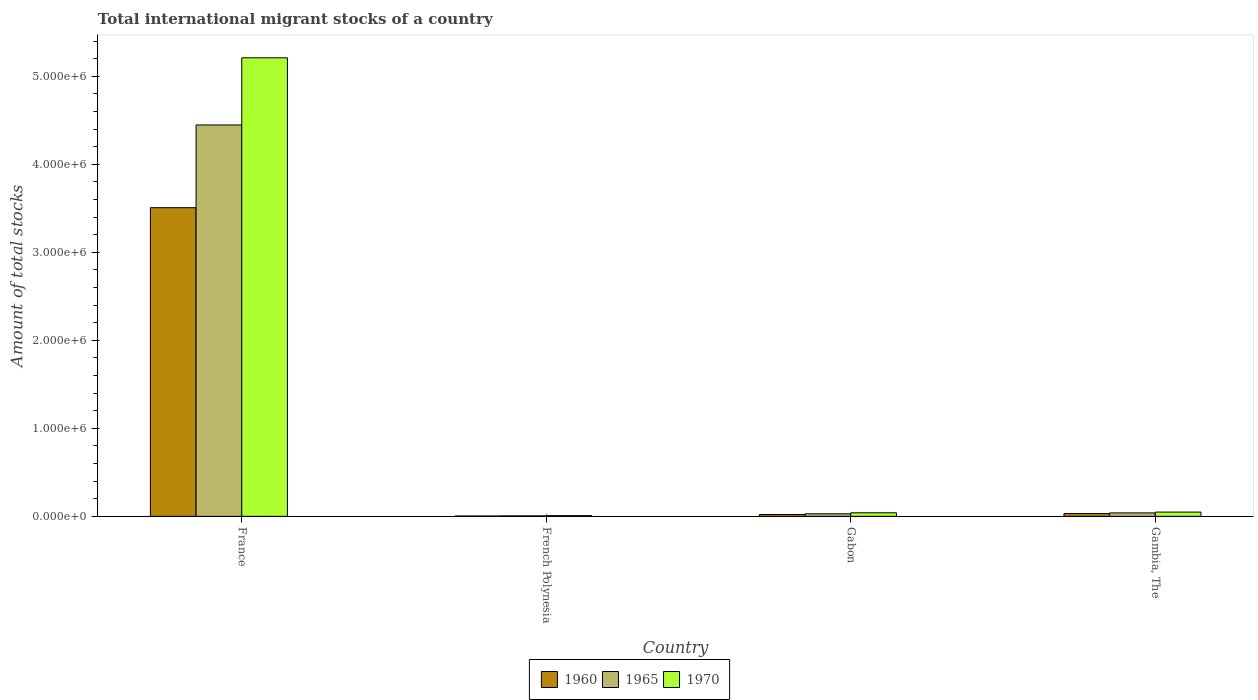How many groups of bars are there?
Make the answer very short. 4. Are the number of bars per tick equal to the number of legend labels?
Provide a short and direct response. Yes. How many bars are there on the 3rd tick from the left?
Ensure brevity in your answer.  3. What is the label of the 4th group of bars from the left?
Offer a terse response. Gambia, The. In how many cases, is the number of bars for a given country not equal to the number of legend labels?
Keep it short and to the point. 0. What is the amount of total stocks in in 1970 in French Polynesia?
Your answer should be very brief. 8194. Across all countries, what is the maximum amount of total stocks in in 1960?
Your response must be concise. 3.51e+06. Across all countries, what is the minimum amount of total stocks in in 1965?
Give a very brief answer. 5480. In which country was the amount of total stocks in in 1970 maximum?
Provide a short and direct response. France. In which country was the amount of total stocks in in 1960 minimum?
Offer a terse response. French Polynesia. What is the total amount of total stocks in in 1960 in the graph?
Your answer should be very brief. 3.56e+06. What is the difference between the amount of total stocks in in 1965 in France and that in Gabon?
Give a very brief answer. 4.42e+06. What is the difference between the amount of total stocks in in 1970 in Gambia, The and the amount of total stocks in in 1965 in French Polynesia?
Make the answer very short. 4.29e+04. What is the average amount of total stocks in in 1960 per country?
Offer a terse response. 8.91e+05. What is the difference between the amount of total stocks in of/in 1965 and amount of total stocks in of/in 1970 in France?
Make the answer very short. -7.63e+05. In how many countries, is the amount of total stocks in in 1960 greater than 4200000?
Provide a succinct answer. 0. What is the ratio of the amount of total stocks in in 1970 in France to that in Gambia, The?
Offer a very short reply. 107.68. Is the amount of total stocks in in 1960 in Gabon less than that in Gambia, The?
Provide a short and direct response. Yes. Is the difference between the amount of total stocks in in 1965 in France and Gabon greater than the difference between the amount of total stocks in in 1970 in France and Gabon?
Provide a short and direct response. No. What is the difference between the highest and the second highest amount of total stocks in in 1965?
Provide a succinct answer. 1.00e+04. What is the difference between the highest and the lowest amount of total stocks in in 1960?
Keep it short and to the point. 3.50e+06. In how many countries, is the amount of total stocks in in 1960 greater than the average amount of total stocks in in 1960 taken over all countries?
Offer a very short reply. 1. What does the 1st bar from the left in Gabon represents?
Offer a very short reply. 1960. Is it the case that in every country, the sum of the amount of total stocks in in 1970 and amount of total stocks in in 1960 is greater than the amount of total stocks in in 1965?
Offer a very short reply. Yes. Are all the bars in the graph horizontal?
Make the answer very short. No. How many countries are there in the graph?
Your answer should be compact. 4. What is the difference between two consecutive major ticks on the Y-axis?
Give a very brief answer. 1.00e+06. Does the graph contain any zero values?
Ensure brevity in your answer.  No. Does the graph contain grids?
Make the answer very short. No. How many legend labels are there?
Your answer should be very brief. 3. How are the legend labels stacked?
Make the answer very short. Horizontal. What is the title of the graph?
Your answer should be very brief. Total international migrant stocks of a country. What is the label or title of the X-axis?
Your response must be concise. Country. What is the label or title of the Y-axis?
Your answer should be compact. Amount of total stocks. What is the Amount of total stocks in 1960 in France?
Offer a terse response. 3.51e+06. What is the Amount of total stocks of 1965 in France?
Offer a very short reply. 4.45e+06. What is the Amount of total stocks of 1970 in France?
Offer a very short reply. 5.21e+06. What is the Amount of total stocks of 1960 in French Polynesia?
Offer a very short reply. 3665. What is the Amount of total stocks in 1965 in French Polynesia?
Offer a very short reply. 5480. What is the Amount of total stocks in 1970 in French Polynesia?
Your answer should be compact. 8194. What is the Amount of total stocks of 1960 in Gabon?
Offer a terse response. 2.09e+04. What is the Amount of total stocks of 1965 in Gabon?
Keep it short and to the point. 2.90e+04. What is the Amount of total stocks in 1970 in Gabon?
Provide a short and direct response. 4.04e+04. What is the Amount of total stocks of 1960 in Gambia, The?
Provide a short and direct response. 3.16e+04. What is the Amount of total stocks of 1965 in Gambia, The?
Your answer should be very brief. 3.91e+04. What is the Amount of total stocks in 1970 in Gambia, The?
Make the answer very short. 4.84e+04. Across all countries, what is the maximum Amount of total stocks of 1960?
Provide a succinct answer. 3.51e+06. Across all countries, what is the maximum Amount of total stocks in 1965?
Your answer should be compact. 4.45e+06. Across all countries, what is the maximum Amount of total stocks in 1970?
Offer a terse response. 5.21e+06. Across all countries, what is the minimum Amount of total stocks in 1960?
Your answer should be very brief. 3665. Across all countries, what is the minimum Amount of total stocks in 1965?
Your answer should be very brief. 5480. Across all countries, what is the minimum Amount of total stocks of 1970?
Your answer should be very brief. 8194. What is the total Amount of total stocks of 1960 in the graph?
Your answer should be very brief. 3.56e+06. What is the total Amount of total stocks in 1965 in the graph?
Your response must be concise. 4.52e+06. What is the total Amount of total stocks in 1970 in the graph?
Ensure brevity in your answer.  5.31e+06. What is the difference between the Amount of total stocks in 1960 in France and that in French Polynesia?
Your answer should be compact. 3.50e+06. What is the difference between the Amount of total stocks of 1965 in France and that in French Polynesia?
Offer a very short reply. 4.44e+06. What is the difference between the Amount of total stocks in 1970 in France and that in French Polynesia?
Keep it short and to the point. 5.20e+06. What is the difference between the Amount of total stocks of 1960 in France and that in Gabon?
Your response must be concise. 3.49e+06. What is the difference between the Amount of total stocks in 1965 in France and that in Gabon?
Your answer should be very brief. 4.42e+06. What is the difference between the Amount of total stocks in 1970 in France and that in Gabon?
Your answer should be very brief. 5.17e+06. What is the difference between the Amount of total stocks of 1960 in France and that in Gambia, The?
Provide a succinct answer. 3.48e+06. What is the difference between the Amount of total stocks of 1965 in France and that in Gambia, The?
Give a very brief answer. 4.41e+06. What is the difference between the Amount of total stocks of 1970 in France and that in Gambia, The?
Provide a short and direct response. 5.16e+06. What is the difference between the Amount of total stocks in 1960 in French Polynesia and that in Gabon?
Your answer should be very brief. -1.72e+04. What is the difference between the Amount of total stocks in 1965 in French Polynesia and that in Gabon?
Keep it short and to the point. -2.36e+04. What is the difference between the Amount of total stocks of 1970 in French Polynesia and that in Gabon?
Offer a terse response. -3.22e+04. What is the difference between the Amount of total stocks in 1960 in French Polynesia and that in Gambia, The?
Give a very brief answer. -2.79e+04. What is the difference between the Amount of total stocks of 1965 in French Polynesia and that in Gambia, The?
Ensure brevity in your answer.  -3.36e+04. What is the difference between the Amount of total stocks of 1970 in French Polynesia and that in Gambia, The?
Offer a terse response. -4.02e+04. What is the difference between the Amount of total stocks in 1960 in Gabon and that in Gambia, The?
Make the answer very short. -1.07e+04. What is the difference between the Amount of total stocks in 1965 in Gabon and that in Gambia, The?
Your answer should be compact. -1.00e+04. What is the difference between the Amount of total stocks of 1970 in Gabon and that in Gambia, The?
Your answer should be very brief. -7998. What is the difference between the Amount of total stocks of 1960 in France and the Amount of total stocks of 1965 in French Polynesia?
Provide a succinct answer. 3.50e+06. What is the difference between the Amount of total stocks of 1960 in France and the Amount of total stocks of 1970 in French Polynesia?
Ensure brevity in your answer.  3.50e+06. What is the difference between the Amount of total stocks in 1965 in France and the Amount of total stocks in 1970 in French Polynesia?
Make the answer very short. 4.44e+06. What is the difference between the Amount of total stocks in 1960 in France and the Amount of total stocks in 1965 in Gabon?
Provide a succinct answer. 3.48e+06. What is the difference between the Amount of total stocks in 1960 in France and the Amount of total stocks in 1970 in Gabon?
Your answer should be compact. 3.47e+06. What is the difference between the Amount of total stocks in 1965 in France and the Amount of total stocks in 1970 in Gabon?
Make the answer very short. 4.41e+06. What is the difference between the Amount of total stocks in 1960 in France and the Amount of total stocks in 1965 in Gambia, The?
Keep it short and to the point. 3.47e+06. What is the difference between the Amount of total stocks in 1960 in France and the Amount of total stocks in 1970 in Gambia, The?
Keep it short and to the point. 3.46e+06. What is the difference between the Amount of total stocks in 1965 in France and the Amount of total stocks in 1970 in Gambia, The?
Offer a terse response. 4.40e+06. What is the difference between the Amount of total stocks in 1960 in French Polynesia and the Amount of total stocks in 1965 in Gabon?
Provide a short and direct response. -2.54e+04. What is the difference between the Amount of total stocks of 1960 in French Polynesia and the Amount of total stocks of 1970 in Gabon?
Your response must be concise. -3.67e+04. What is the difference between the Amount of total stocks of 1965 in French Polynesia and the Amount of total stocks of 1970 in Gabon?
Ensure brevity in your answer.  -3.49e+04. What is the difference between the Amount of total stocks in 1960 in French Polynesia and the Amount of total stocks in 1965 in Gambia, The?
Keep it short and to the point. -3.54e+04. What is the difference between the Amount of total stocks of 1960 in French Polynesia and the Amount of total stocks of 1970 in Gambia, The?
Your answer should be compact. -4.47e+04. What is the difference between the Amount of total stocks in 1965 in French Polynesia and the Amount of total stocks in 1970 in Gambia, The?
Keep it short and to the point. -4.29e+04. What is the difference between the Amount of total stocks in 1960 in Gabon and the Amount of total stocks in 1965 in Gambia, The?
Your answer should be very brief. -1.82e+04. What is the difference between the Amount of total stocks in 1960 in Gabon and the Amount of total stocks in 1970 in Gambia, The?
Your answer should be compact. -2.75e+04. What is the difference between the Amount of total stocks of 1965 in Gabon and the Amount of total stocks of 1970 in Gambia, The?
Provide a short and direct response. -1.94e+04. What is the average Amount of total stocks of 1960 per country?
Provide a short and direct response. 8.91e+05. What is the average Amount of total stocks of 1965 per country?
Make the answer very short. 1.13e+06. What is the average Amount of total stocks in 1970 per country?
Your response must be concise. 1.33e+06. What is the difference between the Amount of total stocks in 1960 and Amount of total stocks in 1965 in France?
Keep it short and to the point. -9.40e+05. What is the difference between the Amount of total stocks in 1960 and Amount of total stocks in 1970 in France?
Your response must be concise. -1.70e+06. What is the difference between the Amount of total stocks in 1965 and Amount of total stocks in 1970 in France?
Ensure brevity in your answer.  -7.63e+05. What is the difference between the Amount of total stocks in 1960 and Amount of total stocks in 1965 in French Polynesia?
Your response must be concise. -1815. What is the difference between the Amount of total stocks of 1960 and Amount of total stocks of 1970 in French Polynesia?
Ensure brevity in your answer.  -4529. What is the difference between the Amount of total stocks in 1965 and Amount of total stocks in 1970 in French Polynesia?
Offer a very short reply. -2714. What is the difference between the Amount of total stocks in 1960 and Amount of total stocks in 1965 in Gabon?
Offer a terse response. -8165. What is the difference between the Amount of total stocks in 1960 and Amount of total stocks in 1970 in Gabon?
Provide a succinct answer. -1.95e+04. What is the difference between the Amount of total stocks of 1965 and Amount of total stocks of 1970 in Gabon?
Offer a terse response. -1.14e+04. What is the difference between the Amount of total stocks in 1960 and Amount of total stocks in 1965 in Gambia, The?
Ensure brevity in your answer.  -7522. What is the difference between the Amount of total stocks of 1960 and Amount of total stocks of 1970 in Gambia, The?
Your answer should be very brief. -1.68e+04. What is the difference between the Amount of total stocks in 1965 and Amount of total stocks in 1970 in Gambia, The?
Provide a succinct answer. -9316. What is the ratio of the Amount of total stocks of 1960 in France to that in French Polynesia?
Offer a very short reply. 956.95. What is the ratio of the Amount of total stocks in 1965 in France to that in French Polynesia?
Make the answer very short. 811.54. What is the ratio of the Amount of total stocks of 1970 in France to that in French Polynesia?
Keep it short and to the point. 635.87. What is the ratio of the Amount of total stocks of 1960 in France to that in Gabon?
Provide a succinct answer. 168.09. What is the ratio of the Amount of total stocks of 1965 in France to that in Gabon?
Your answer should be compact. 153.19. What is the ratio of the Amount of total stocks in 1970 in France to that in Gabon?
Your answer should be very brief. 129. What is the ratio of the Amount of total stocks in 1960 in France to that in Gambia, The?
Offer a very short reply. 111.16. What is the ratio of the Amount of total stocks in 1965 in France to that in Gambia, The?
Make the answer very short. 113.82. What is the ratio of the Amount of total stocks in 1970 in France to that in Gambia, The?
Provide a succinct answer. 107.68. What is the ratio of the Amount of total stocks in 1960 in French Polynesia to that in Gabon?
Provide a succinct answer. 0.18. What is the ratio of the Amount of total stocks in 1965 in French Polynesia to that in Gabon?
Keep it short and to the point. 0.19. What is the ratio of the Amount of total stocks in 1970 in French Polynesia to that in Gabon?
Make the answer very short. 0.2. What is the ratio of the Amount of total stocks in 1960 in French Polynesia to that in Gambia, The?
Ensure brevity in your answer.  0.12. What is the ratio of the Amount of total stocks of 1965 in French Polynesia to that in Gambia, The?
Provide a succinct answer. 0.14. What is the ratio of the Amount of total stocks of 1970 in French Polynesia to that in Gambia, The?
Make the answer very short. 0.17. What is the ratio of the Amount of total stocks of 1960 in Gabon to that in Gambia, The?
Provide a short and direct response. 0.66. What is the ratio of the Amount of total stocks of 1965 in Gabon to that in Gambia, The?
Offer a terse response. 0.74. What is the ratio of the Amount of total stocks of 1970 in Gabon to that in Gambia, The?
Ensure brevity in your answer.  0.83. What is the difference between the highest and the second highest Amount of total stocks in 1960?
Provide a short and direct response. 3.48e+06. What is the difference between the highest and the second highest Amount of total stocks in 1965?
Ensure brevity in your answer.  4.41e+06. What is the difference between the highest and the second highest Amount of total stocks in 1970?
Give a very brief answer. 5.16e+06. What is the difference between the highest and the lowest Amount of total stocks in 1960?
Your answer should be compact. 3.50e+06. What is the difference between the highest and the lowest Amount of total stocks of 1965?
Your answer should be compact. 4.44e+06. What is the difference between the highest and the lowest Amount of total stocks in 1970?
Ensure brevity in your answer.  5.20e+06. 